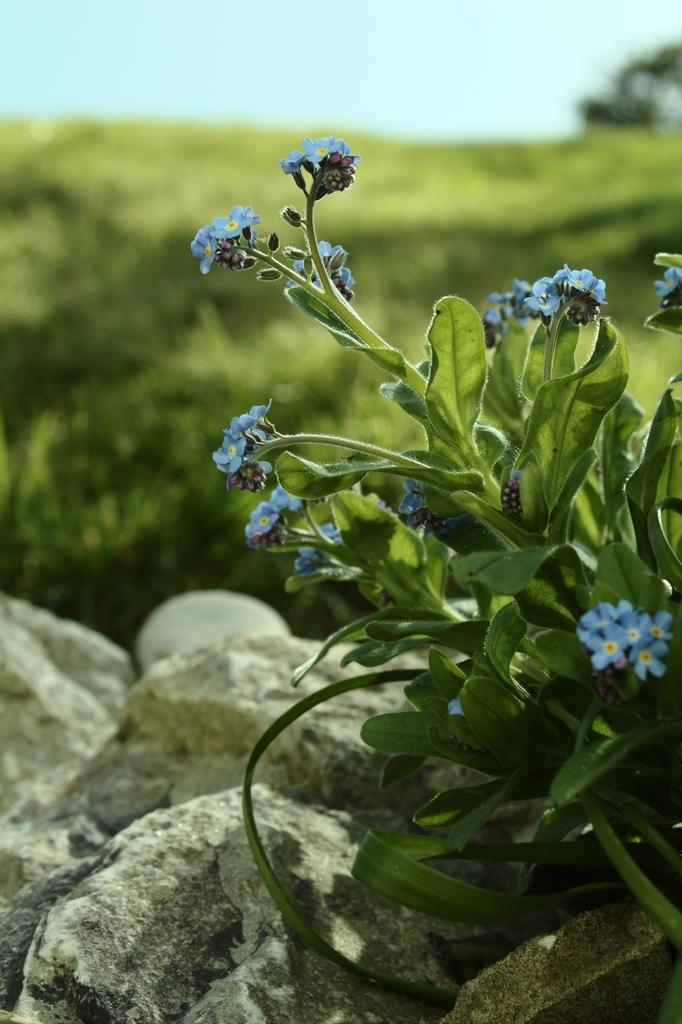What type of plant is on the right side of the image? There is a plant with blue flowers on the right side of the image. What can be seen on the left side of the image? There are rocks on the left side of the image. Can you describe the background of the image? The background of the image is blurred. What type of oven is visible in the image? There is no oven present in the image. How many eyes can be seen on the plant with blue flowers? The plant with blue flowers does not have eyes, as it is a non-living organism. 